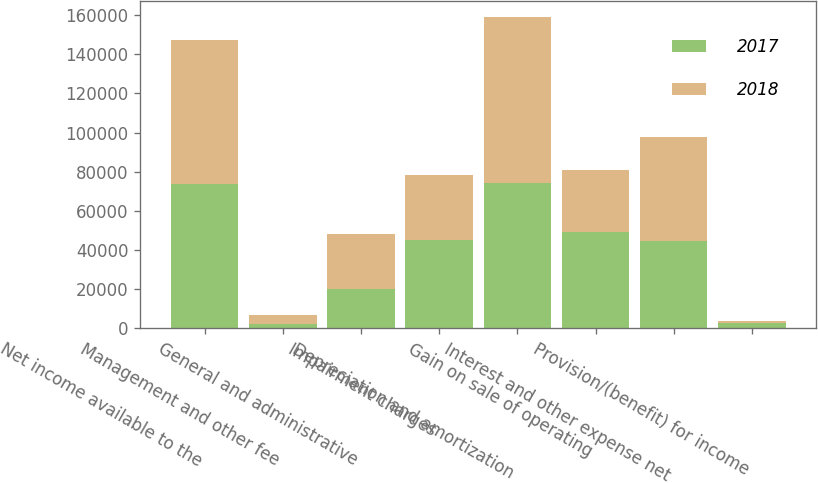Convert chart. <chart><loc_0><loc_0><loc_500><loc_500><stacked_bar_chart><ecel><fcel>Net income available to the<fcel>Management and other fee<fcel>General and administrative<fcel>Impairment charges<fcel>Depreciation and amortization<fcel>Gain on sale of operating<fcel>Interest and other expense net<fcel>Provision/(benefit) for income<nl><fcel>2017<fcel>73627<fcel>2397<fcel>20022<fcel>45352<fcel>74266<fcel>49379<fcel>44515<fcel>2583<nl><fcel>2018<fcel>73465<fcel>4593<fcel>27972<fcel>33051<fcel>85024<fcel>31436<fcel>53380<fcel>1344<nl></chart> 